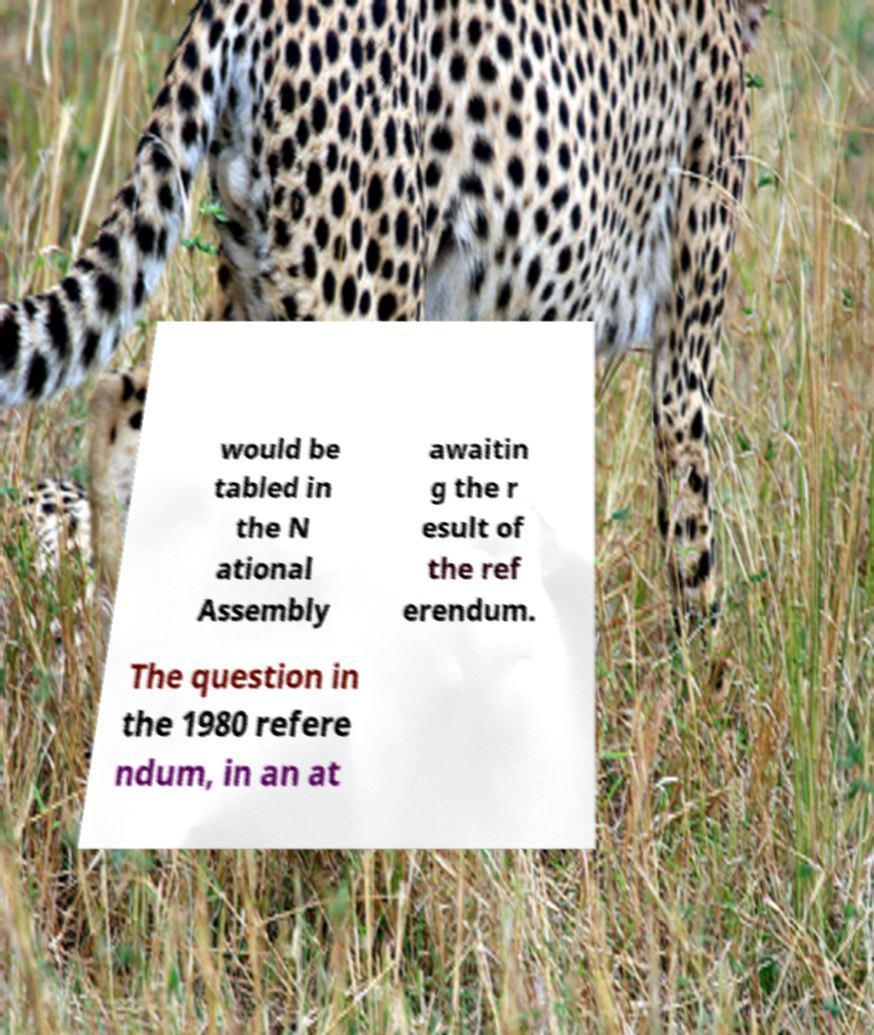Can you read and provide the text displayed in the image?This photo seems to have some interesting text. Can you extract and type it out for me? would be tabled in the N ational Assembly awaitin g the r esult of the ref erendum. The question in the 1980 refere ndum, in an at 